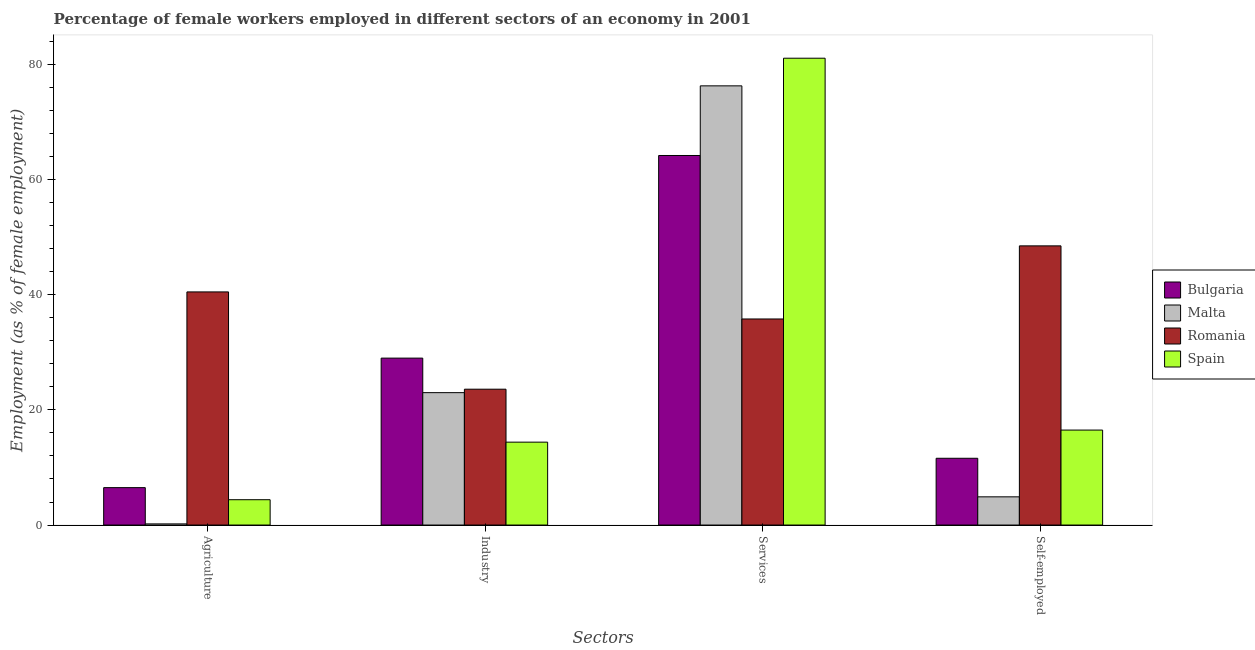Are the number of bars per tick equal to the number of legend labels?
Offer a terse response. Yes. Are the number of bars on each tick of the X-axis equal?
Provide a short and direct response. Yes. How many bars are there on the 4th tick from the left?
Provide a succinct answer. 4. What is the label of the 3rd group of bars from the left?
Provide a succinct answer. Services. What is the percentage of self employed female workers in Romania?
Give a very brief answer. 48.5. Across all countries, what is the maximum percentage of female workers in agriculture?
Your answer should be compact. 40.5. Across all countries, what is the minimum percentage of female workers in agriculture?
Your response must be concise. 0.2. In which country was the percentage of female workers in services minimum?
Offer a very short reply. Romania. What is the difference between the percentage of female workers in agriculture in Spain and that in Bulgaria?
Offer a terse response. -2.1. What is the difference between the percentage of female workers in services in Malta and the percentage of self employed female workers in Bulgaria?
Your answer should be compact. 64.7. What is the average percentage of female workers in agriculture per country?
Provide a short and direct response. 12.9. What is the difference between the percentage of female workers in industry and percentage of female workers in services in Bulgaria?
Your answer should be compact. -35.2. What is the ratio of the percentage of self employed female workers in Malta to that in Bulgaria?
Your answer should be very brief. 0.42. Is the percentage of female workers in agriculture in Malta less than that in Spain?
Make the answer very short. Yes. Is the difference between the percentage of female workers in agriculture in Malta and Romania greater than the difference between the percentage of female workers in services in Malta and Romania?
Give a very brief answer. No. What is the difference between the highest and the second highest percentage of female workers in services?
Provide a short and direct response. 4.8. What is the difference between the highest and the lowest percentage of self employed female workers?
Your answer should be compact. 43.6. In how many countries, is the percentage of self employed female workers greater than the average percentage of self employed female workers taken over all countries?
Your response must be concise. 1. Is the sum of the percentage of female workers in services in Spain and Malta greater than the maximum percentage of female workers in industry across all countries?
Your answer should be very brief. Yes. What does the 1st bar from the left in Self-employed represents?
Your answer should be compact. Bulgaria. What does the 1st bar from the right in Services represents?
Provide a short and direct response. Spain. Is it the case that in every country, the sum of the percentage of female workers in agriculture and percentage of female workers in industry is greater than the percentage of female workers in services?
Your answer should be very brief. No. How many bars are there?
Your answer should be compact. 16. Are the values on the major ticks of Y-axis written in scientific E-notation?
Ensure brevity in your answer.  No. Does the graph contain any zero values?
Your response must be concise. No. Does the graph contain grids?
Offer a very short reply. No. How many legend labels are there?
Give a very brief answer. 4. What is the title of the graph?
Make the answer very short. Percentage of female workers employed in different sectors of an economy in 2001. What is the label or title of the X-axis?
Provide a short and direct response. Sectors. What is the label or title of the Y-axis?
Give a very brief answer. Employment (as % of female employment). What is the Employment (as % of female employment) in Malta in Agriculture?
Offer a very short reply. 0.2. What is the Employment (as % of female employment) in Romania in Agriculture?
Offer a very short reply. 40.5. What is the Employment (as % of female employment) in Spain in Agriculture?
Offer a very short reply. 4.4. What is the Employment (as % of female employment) of Romania in Industry?
Offer a very short reply. 23.6. What is the Employment (as % of female employment) of Spain in Industry?
Offer a terse response. 14.4. What is the Employment (as % of female employment) in Bulgaria in Services?
Your answer should be very brief. 64.2. What is the Employment (as % of female employment) in Malta in Services?
Provide a short and direct response. 76.3. What is the Employment (as % of female employment) in Romania in Services?
Provide a short and direct response. 35.8. What is the Employment (as % of female employment) of Spain in Services?
Your answer should be very brief. 81.1. What is the Employment (as % of female employment) in Bulgaria in Self-employed?
Ensure brevity in your answer.  11.6. What is the Employment (as % of female employment) of Malta in Self-employed?
Ensure brevity in your answer.  4.9. What is the Employment (as % of female employment) in Romania in Self-employed?
Offer a terse response. 48.5. Across all Sectors, what is the maximum Employment (as % of female employment) in Bulgaria?
Keep it short and to the point. 64.2. Across all Sectors, what is the maximum Employment (as % of female employment) in Malta?
Offer a very short reply. 76.3. Across all Sectors, what is the maximum Employment (as % of female employment) of Romania?
Provide a short and direct response. 48.5. Across all Sectors, what is the maximum Employment (as % of female employment) in Spain?
Give a very brief answer. 81.1. Across all Sectors, what is the minimum Employment (as % of female employment) in Malta?
Keep it short and to the point. 0.2. Across all Sectors, what is the minimum Employment (as % of female employment) in Romania?
Ensure brevity in your answer.  23.6. Across all Sectors, what is the minimum Employment (as % of female employment) in Spain?
Keep it short and to the point. 4.4. What is the total Employment (as % of female employment) of Bulgaria in the graph?
Your answer should be very brief. 111.3. What is the total Employment (as % of female employment) of Malta in the graph?
Your answer should be compact. 104.4. What is the total Employment (as % of female employment) in Romania in the graph?
Offer a terse response. 148.4. What is the total Employment (as % of female employment) in Spain in the graph?
Give a very brief answer. 116.4. What is the difference between the Employment (as % of female employment) in Bulgaria in Agriculture and that in Industry?
Your answer should be very brief. -22.5. What is the difference between the Employment (as % of female employment) of Malta in Agriculture and that in Industry?
Ensure brevity in your answer.  -22.8. What is the difference between the Employment (as % of female employment) of Spain in Agriculture and that in Industry?
Offer a very short reply. -10. What is the difference between the Employment (as % of female employment) in Bulgaria in Agriculture and that in Services?
Make the answer very short. -57.7. What is the difference between the Employment (as % of female employment) in Malta in Agriculture and that in Services?
Give a very brief answer. -76.1. What is the difference between the Employment (as % of female employment) in Spain in Agriculture and that in Services?
Keep it short and to the point. -76.7. What is the difference between the Employment (as % of female employment) of Bulgaria in Industry and that in Services?
Make the answer very short. -35.2. What is the difference between the Employment (as % of female employment) of Malta in Industry and that in Services?
Make the answer very short. -53.3. What is the difference between the Employment (as % of female employment) of Romania in Industry and that in Services?
Your answer should be very brief. -12.2. What is the difference between the Employment (as % of female employment) of Spain in Industry and that in Services?
Give a very brief answer. -66.7. What is the difference between the Employment (as % of female employment) of Bulgaria in Industry and that in Self-employed?
Ensure brevity in your answer.  17.4. What is the difference between the Employment (as % of female employment) in Romania in Industry and that in Self-employed?
Make the answer very short. -24.9. What is the difference between the Employment (as % of female employment) of Bulgaria in Services and that in Self-employed?
Your answer should be very brief. 52.6. What is the difference between the Employment (as % of female employment) in Malta in Services and that in Self-employed?
Give a very brief answer. 71.4. What is the difference between the Employment (as % of female employment) of Romania in Services and that in Self-employed?
Offer a very short reply. -12.7. What is the difference between the Employment (as % of female employment) in Spain in Services and that in Self-employed?
Give a very brief answer. 64.6. What is the difference between the Employment (as % of female employment) of Bulgaria in Agriculture and the Employment (as % of female employment) of Malta in Industry?
Offer a terse response. -16.5. What is the difference between the Employment (as % of female employment) in Bulgaria in Agriculture and the Employment (as % of female employment) in Romania in Industry?
Offer a terse response. -17.1. What is the difference between the Employment (as % of female employment) in Bulgaria in Agriculture and the Employment (as % of female employment) in Spain in Industry?
Provide a succinct answer. -7.9. What is the difference between the Employment (as % of female employment) of Malta in Agriculture and the Employment (as % of female employment) of Romania in Industry?
Your answer should be compact. -23.4. What is the difference between the Employment (as % of female employment) in Romania in Agriculture and the Employment (as % of female employment) in Spain in Industry?
Ensure brevity in your answer.  26.1. What is the difference between the Employment (as % of female employment) in Bulgaria in Agriculture and the Employment (as % of female employment) in Malta in Services?
Your response must be concise. -69.8. What is the difference between the Employment (as % of female employment) in Bulgaria in Agriculture and the Employment (as % of female employment) in Romania in Services?
Ensure brevity in your answer.  -29.3. What is the difference between the Employment (as % of female employment) of Bulgaria in Agriculture and the Employment (as % of female employment) of Spain in Services?
Ensure brevity in your answer.  -74.6. What is the difference between the Employment (as % of female employment) of Malta in Agriculture and the Employment (as % of female employment) of Romania in Services?
Provide a short and direct response. -35.6. What is the difference between the Employment (as % of female employment) in Malta in Agriculture and the Employment (as % of female employment) in Spain in Services?
Make the answer very short. -80.9. What is the difference between the Employment (as % of female employment) of Romania in Agriculture and the Employment (as % of female employment) of Spain in Services?
Provide a short and direct response. -40.6. What is the difference between the Employment (as % of female employment) of Bulgaria in Agriculture and the Employment (as % of female employment) of Malta in Self-employed?
Offer a very short reply. 1.6. What is the difference between the Employment (as % of female employment) in Bulgaria in Agriculture and the Employment (as % of female employment) in Romania in Self-employed?
Keep it short and to the point. -42. What is the difference between the Employment (as % of female employment) in Bulgaria in Agriculture and the Employment (as % of female employment) in Spain in Self-employed?
Ensure brevity in your answer.  -10. What is the difference between the Employment (as % of female employment) in Malta in Agriculture and the Employment (as % of female employment) in Romania in Self-employed?
Offer a very short reply. -48.3. What is the difference between the Employment (as % of female employment) of Malta in Agriculture and the Employment (as % of female employment) of Spain in Self-employed?
Offer a very short reply. -16.3. What is the difference between the Employment (as % of female employment) of Bulgaria in Industry and the Employment (as % of female employment) of Malta in Services?
Offer a terse response. -47.3. What is the difference between the Employment (as % of female employment) in Bulgaria in Industry and the Employment (as % of female employment) in Spain in Services?
Keep it short and to the point. -52.1. What is the difference between the Employment (as % of female employment) of Malta in Industry and the Employment (as % of female employment) of Spain in Services?
Give a very brief answer. -58.1. What is the difference between the Employment (as % of female employment) of Romania in Industry and the Employment (as % of female employment) of Spain in Services?
Ensure brevity in your answer.  -57.5. What is the difference between the Employment (as % of female employment) of Bulgaria in Industry and the Employment (as % of female employment) of Malta in Self-employed?
Give a very brief answer. 24.1. What is the difference between the Employment (as % of female employment) of Bulgaria in Industry and the Employment (as % of female employment) of Romania in Self-employed?
Give a very brief answer. -19.5. What is the difference between the Employment (as % of female employment) of Malta in Industry and the Employment (as % of female employment) of Romania in Self-employed?
Your response must be concise. -25.5. What is the difference between the Employment (as % of female employment) in Malta in Industry and the Employment (as % of female employment) in Spain in Self-employed?
Your answer should be compact. 6.5. What is the difference between the Employment (as % of female employment) of Bulgaria in Services and the Employment (as % of female employment) of Malta in Self-employed?
Offer a very short reply. 59.3. What is the difference between the Employment (as % of female employment) in Bulgaria in Services and the Employment (as % of female employment) in Spain in Self-employed?
Your response must be concise. 47.7. What is the difference between the Employment (as % of female employment) of Malta in Services and the Employment (as % of female employment) of Romania in Self-employed?
Give a very brief answer. 27.8. What is the difference between the Employment (as % of female employment) of Malta in Services and the Employment (as % of female employment) of Spain in Self-employed?
Your answer should be very brief. 59.8. What is the difference between the Employment (as % of female employment) of Romania in Services and the Employment (as % of female employment) of Spain in Self-employed?
Offer a terse response. 19.3. What is the average Employment (as % of female employment) in Bulgaria per Sectors?
Your response must be concise. 27.82. What is the average Employment (as % of female employment) in Malta per Sectors?
Your answer should be very brief. 26.1. What is the average Employment (as % of female employment) in Romania per Sectors?
Ensure brevity in your answer.  37.1. What is the average Employment (as % of female employment) of Spain per Sectors?
Give a very brief answer. 29.1. What is the difference between the Employment (as % of female employment) in Bulgaria and Employment (as % of female employment) in Romania in Agriculture?
Offer a terse response. -34. What is the difference between the Employment (as % of female employment) of Bulgaria and Employment (as % of female employment) of Spain in Agriculture?
Offer a very short reply. 2.1. What is the difference between the Employment (as % of female employment) of Malta and Employment (as % of female employment) of Romania in Agriculture?
Your answer should be compact. -40.3. What is the difference between the Employment (as % of female employment) in Romania and Employment (as % of female employment) in Spain in Agriculture?
Provide a short and direct response. 36.1. What is the difference between the Employment (as % of female employment) of Bulgaria and Employment (as % of female employment) of Malta in Industry?
Make the answer very short. 6. What is the difference between the Employment (as % of female employment) of Bulgaria and Employment (as % of female employment) of Romania in Industry?
Make the answer very short. 5.4. What is the difference between the Employment (as % of female employment) in Bulgaria and Employment (as % of female employment) in Spain in Industry?
Offer a terse response. 14.6. What is the difference between the Employment (as % of female employment) of Malta and Employment (as % of female employment) of Spain in Industry?
Provide a short and direct response. 8.6. What is the difference between the Employment (as % of female employment) in Romania and Employment (as % of female employment) in Spain in Industry?
Keep it short and to the point. 9.2. What is the difference between the Employment (as % of female employment) of Bulgaria and Employment (as % of female employment) of Romania in Services?
Make the answer very short. 28.4. What is the difference between the Employment (as % of female employment) in Bulgaria and Employment (as % of female employment) in Spain in Services?
Provide a succinct answer. -16.9. What is the difference between the Employment (as % of female employment) in Malta and Employment (as % of female employment) in Romania in Services?
Offer a terse response. 40.5. What is the difference between the Employment (as % of female employment) of Malta and Employment (as % of female employment) of Spain in Services?
Offer a terse response. -4.8. What is the difference between the Employment (as % of female employment) of Romania and Employment (as % of female employment) of Spain in Services?
Give a very brief answer. -45.3. What is the difference between the Employment (as % of female employment) in Bulgaria and Employment (as % of female employment) in Romania in Self-employed?
Provide a succinct answer. -36.9. What is the difference between the Employment (as % of female employment) of Malta and Employment (as % of female employment) of Romania in Self-employed?
Ensure brevity in your answer.  -43.6. What is the difference between the Employment (as % of female employment) in Malta and Employment (as % of female employment) in Spain in Self-employed?
Keep it short and to the point. -11.6. What is the ratio of the Employment (as % of female employment) in Bulgaria in Agriculture to that in Industry?
Provide a short and direct response. 0.22. What is the ratio of the Employment (as % of female employment) in Malta in Agriculture to that in Industry?
Keep it short and to the point. 0.01. What is the ratio of the Employment (as % of female employment) in Romania in Agriculture to that in Industry?
Your answer should be very brief. 1.72. What is the ratio of the Employment (as % of female employment) of Spain in Agriculture to that in Industry?
Offer a terse response. 0.31. What is the ratio of the Employment (as % of female employment) of Bulgaria in Agriculture to that in Services?
Offer a very short reply. 0.1. What is the ratio of the Employment (as % of female employment) of Malta in Agriculture to that in Services?
Your answer should be compact. 0. What is the ratio of the Employment (as % of female employment) of Romania in Agriculture to that in Services?
Your answer should be compact. 1.13. What is the ratio of the Employment (as % of female employment) of Spain in Agriculture to that in Services?
Give a very brief answer. 0.05. What is the ratio of the Employment (as % of female employment) in Bulgaria in Agriculture to that in Self-employed?
Provide a succinct answer. 0.56. What is the ratio of the Employment (as % of female employment) in Malta in Agriculture to that in Self-employed?
Offer a very short reply. 0.04. What is the ratio of the Employment (as % of female employment) in Romania in Agriculture to that in Self-employed?
Ensure brevity in your answer.  0.84. What is the ratio of the Employment (as % of female employment) of Spain in Agriculture to that in Self-employed?
Ensure brevity in your answer.  0.27. What is the ratio of the Employment (as % of female employment) in Bulgaria in Industry to that in Services?
Your response must be concise. 0.45. What is the ratio of the Employment (as % of female employment) of Malta in Industry to that in Services?
Offer a very short reply. 0.3. What is the ratio of the Employment (as % of female employment) in Romania in Industry to that in Services?
Your answer should be very brief. 0.66. What is the ratio of the Employment (as % of female employment) of Spain in Industry to that in Services?
Your answer should be compact. 0.18. What is the ratio of the Employment (as % of female employment) in Malta in Industry to that in Self-employed?
Your answer should be compact. 4.69. What is the ratio of the Employment (as % of female employment) in Romania in Industry to that in Self-employed?
Keep it short and to the point. 0.49. What is the ratio of the Employment (as % of female employment) of Spain in Industry to that in Self-employed?
Your response must be concise. 0.87. What is the ratio of the Employment (as % of female employment) of Bulgaria in Services to that in Self-employed?
Your response must be concise. 5.53. What is the ratio of the Employment (as % of female employment) in Malta in Services to that in Self-employed?
Make the answer very short. 15.57. What is the ratio of the Employment (as % of female employment) of Romania in Services to that in Self-employed?
Your answer should be compact. 0.74. What is the ratio of the Employment (as % of female employment) in Spain in Services to that in Self-employed?
Your response must be concise. 4.92. What is the difference between the highest and the second highest Employment (as % of female employment) of Bulgaria?
Offer a terse response. 35.2. What is the difference between the highest and the second highest Employment (as % of female employment) in Malta?
Give a very brief answer. 53.3. What is the difference between the highest and the second highest Employment (as % of female employment) in Romania?
Your response must be concise. 8. What is the difference between the highest and the second highest Employment (as % of female employment) of Spain?
Keep it short and to the point. 64.6. What is the difference between the highest and the lowest Employment (as % of female employment) of Bulgaria?
Offer a terse response. 57.7. What is the difference between the highest and the lowest Employment (as % of female employment) in Malta?
Your answer should be compact. 76.1. What is the difference between the highest and the lowest Employment (as % of female employment) of Romania?
Offer a terse response. 24.9. What is the difference between the highest and the lowest Employment (as % of female employment) of Spain?
Your answer should be very brief. 76.7. 